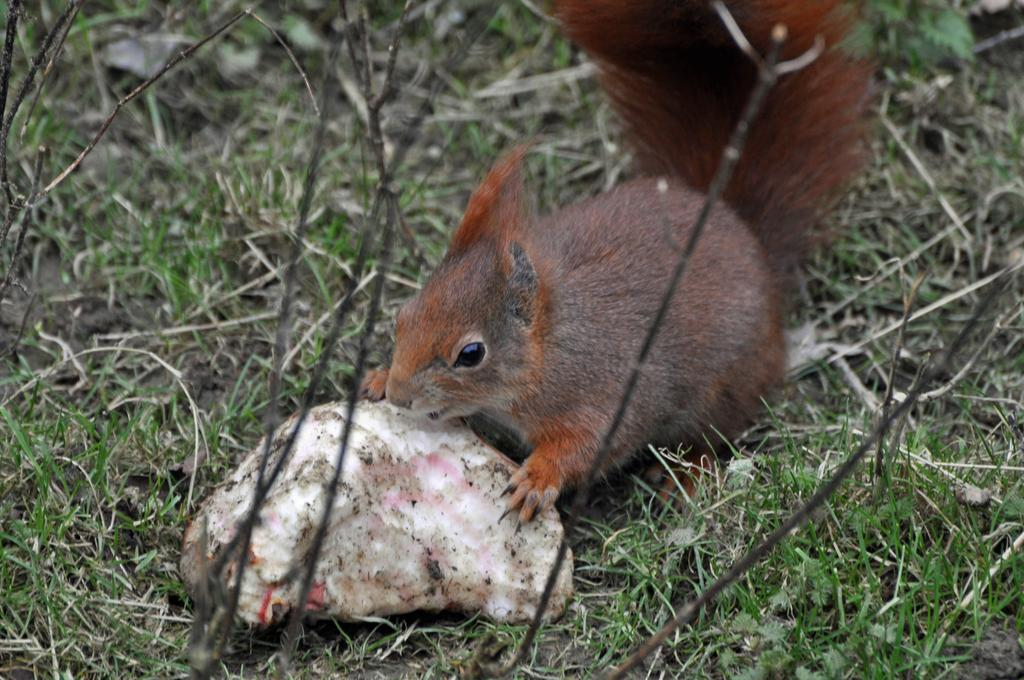What type of animal can be seen in the image? There is a squirrel in the image. What is located on the ground in the image? There is an object on the ground in the image. What type of vegetation is visible in the background of the image? There is grass visible in the background of the image. What month is depicted in the image? There is no specific month depicted in the image; it only shows a squirrel, an object on the ground, and grass in the background. 